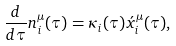Convert formula to latex. <formula><loc_0><loc_0><loc_500><loc_500>\frac { d } { d \tau } n _ { i } ^ { \mu } ( \tau ) = \kappa _ { i } ( \tau ) \acute { x } _ { i } ^ { \mu } ( \tau ) ,</formula> 